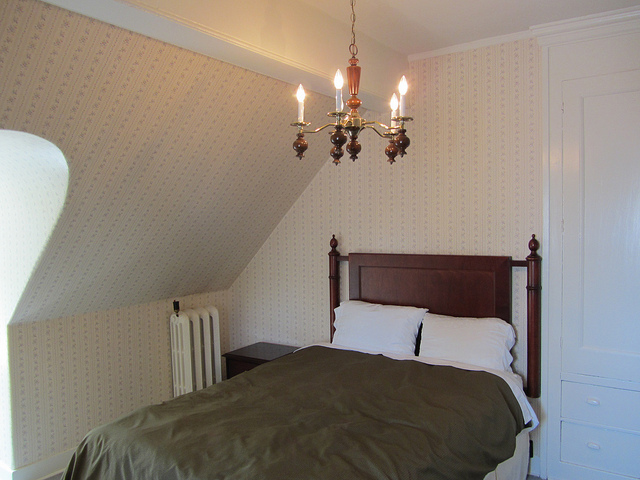<image>Is the sidewall too low? It is ambiguous if the sidewall is too low. It depends on the context. Is the sidewall too low? I don't know if the sidewall is too low. It can depend on the perspective or the specific situation. 